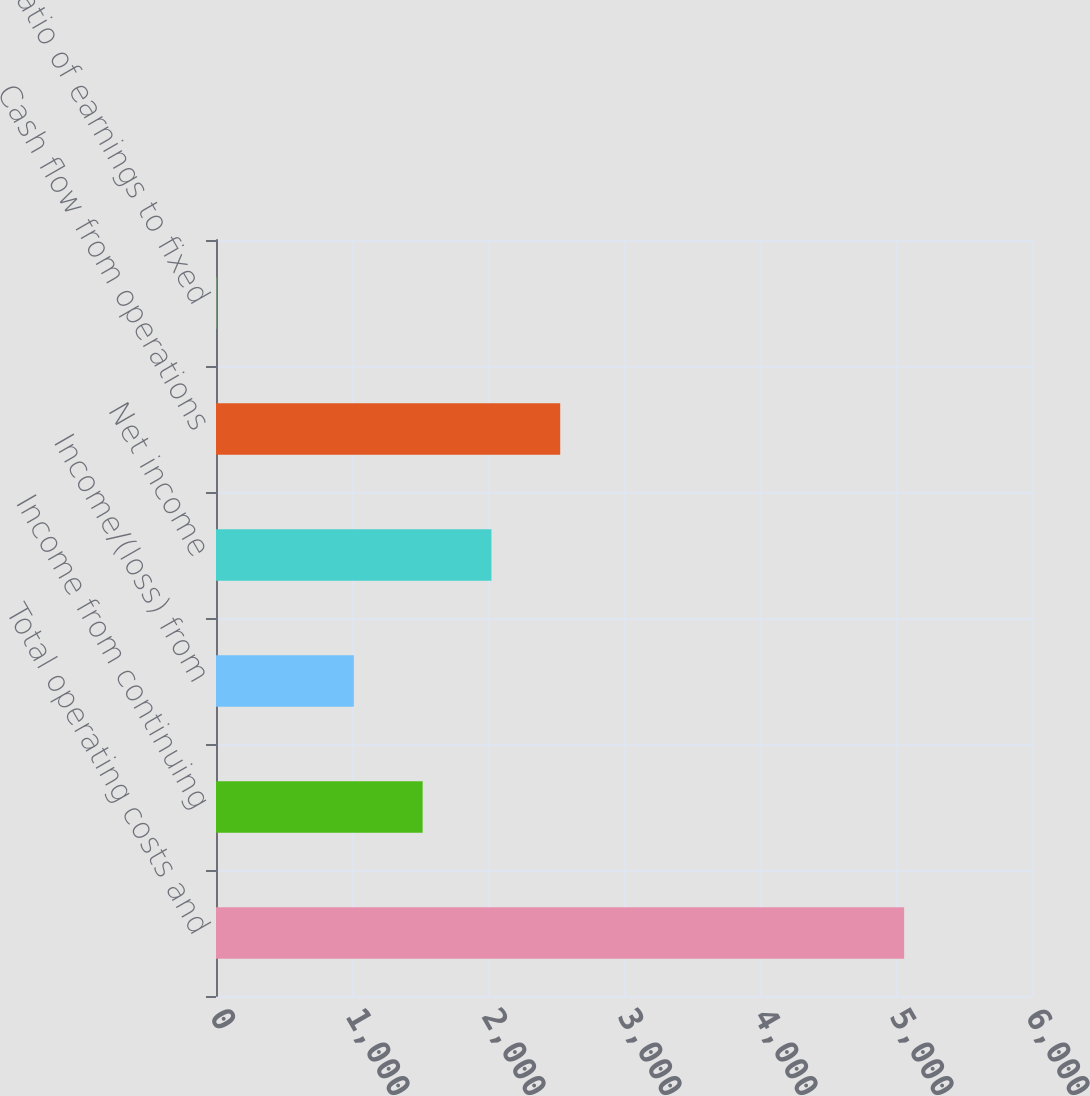<chart> <loc_0><loc_0><loc_500><loc_500><bar_chart><fcel>Total operating costs and<fcel>Income from continuing<fcel>Income/(loss) from<fcel>Net income<fcel>Cash flow from operations<fcel>Ratio of earnings to fixed<nl><fcel>5060<fcel>1519.43<fcel>1013.63<fcel>2025.23<fcel>2531.03<fcel>2.03<nl></chart> 